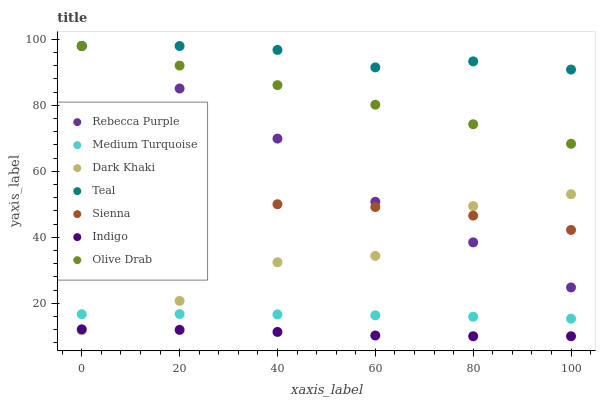Does Indigo have the minimum area under the curve?
Answer yes or no. Yes. Does Teal have the maximum area under the curve?
Answer yes or no. Yes. Does Medium Turquoise have the minimum area under the curve?
Answer yes or no. No. Does Medium Turquoise have the maximum area under the curve?
Answer yes or no. No. Is Olive Drab the smoothest?
Answer yes or no. Yes. Is Dark Khaki the roughest?
Answer yes or no. Yes. Is Indigo the smoothest?
Answer yes or no. No. Is Indigo the roughest?
Answer yes or no. No. Does Indigo have the lowest value?
Answer yes or no. Yes. Does Medium Turquoise have the lowest value?
Answer yes or no. No. Does Olive Drab have the highest value?
Answer yes or no. Yes. Does Medium Turquoise have the highest value?
Answer yes or no. No. Is Indigo less than Teal?
Answer yes or no. Yes. Is Teal greater than Dark Khaki?
Answer yes or no. Yes. Does Teal intersect Olive Drab?
Answer yes or no. Yes. Is Teal less than Olive Drab?
Answer yes or no. No. Is Teal greater than Olive Drab?
Answer yes or no. No. Does Indigo intersect Teal?
Answer yes or no. No. 